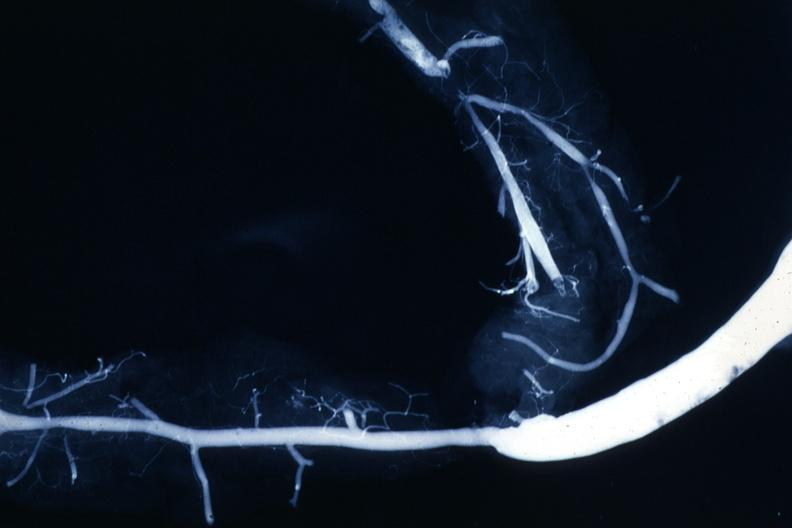does fibrinous peritonitis show shows rather close-up large vein anastomosing to much smaller artery?
Answer the question using a single word or phrase. No 